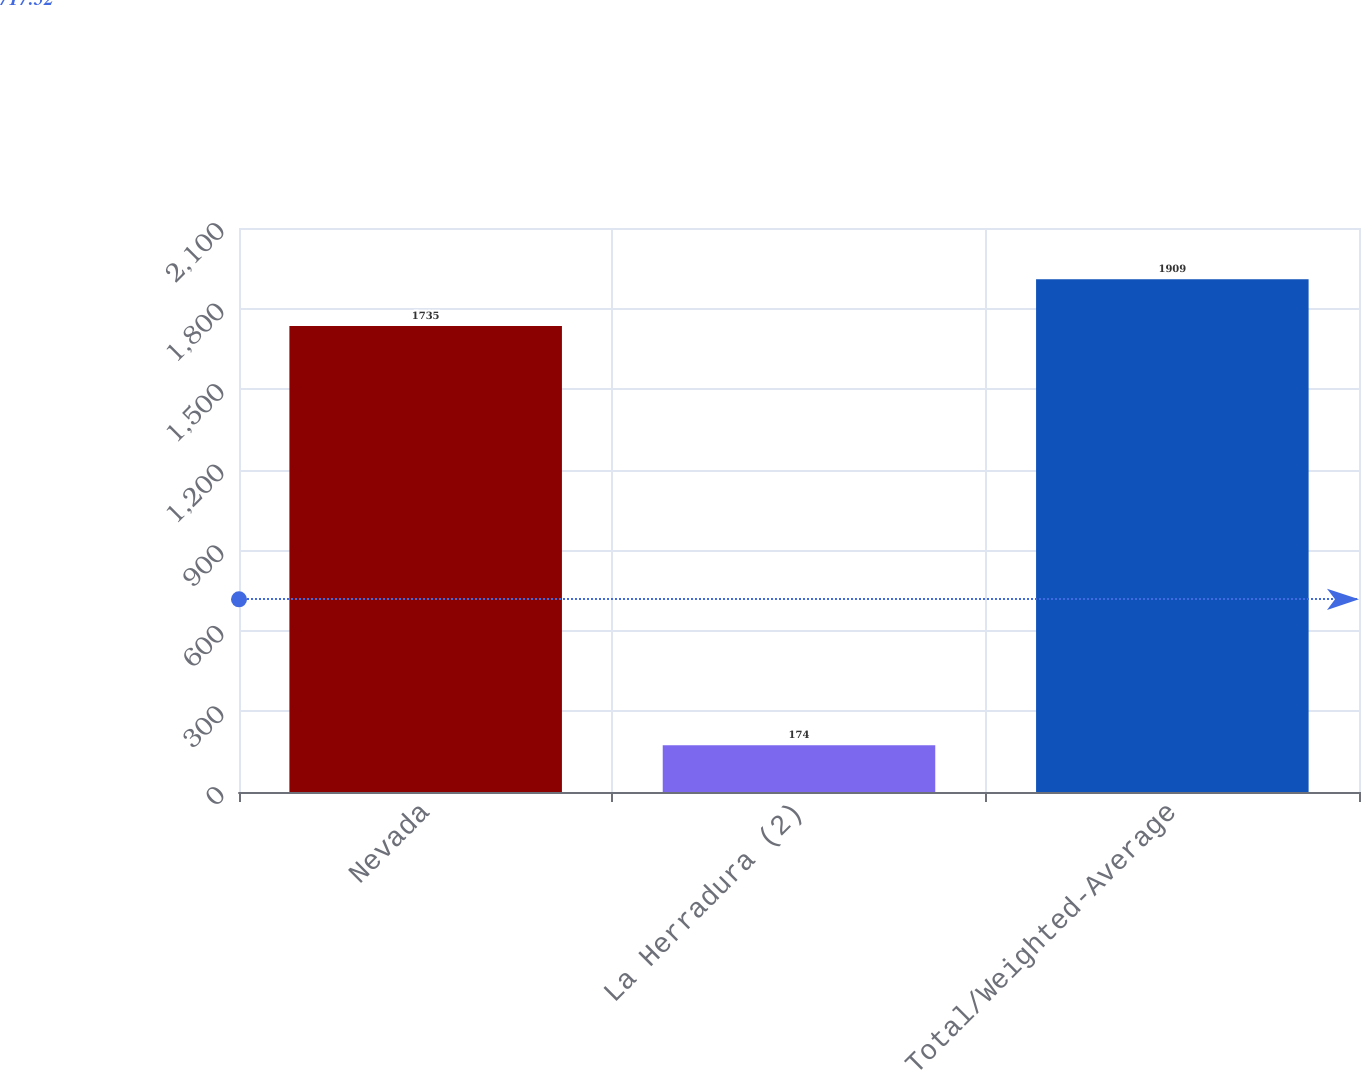<chart> <loc_0><loc_0><loc_500><loc_500><bar_chart><fcel>Nevada<fcel>La Herradura (2)<fcel>Total/Weighted-Average<nl><fcel>1735<fcel>174<fcel>1909<nl></chart> 